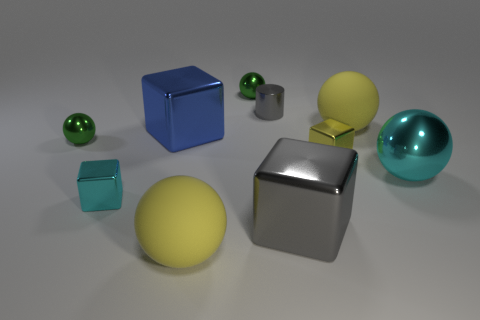Subtract all gray shiny blocks. How many blocks are left? 3 Subtract 2 cubes. How many cubes are left? 2 Subtract all blue blocks. How many blocks are left? 3 Subtract all tiny green shiny things. Subtract all cyan shiny blocks. How many objects are left? 7 Add 1 matte spheres. How many matte spheres are left? 3 Add 5 small cyan objects. How many small cyan objects exist? 6 Subtract 1 blue blocks. How many objects are left? 9 Subtract all cylinders. How many objects are left? 9 Subtract all brown balls. Subtract all green blocks. How many balls are left? 5 Subtract all gray spheres. How many gray cubes are left? 1 